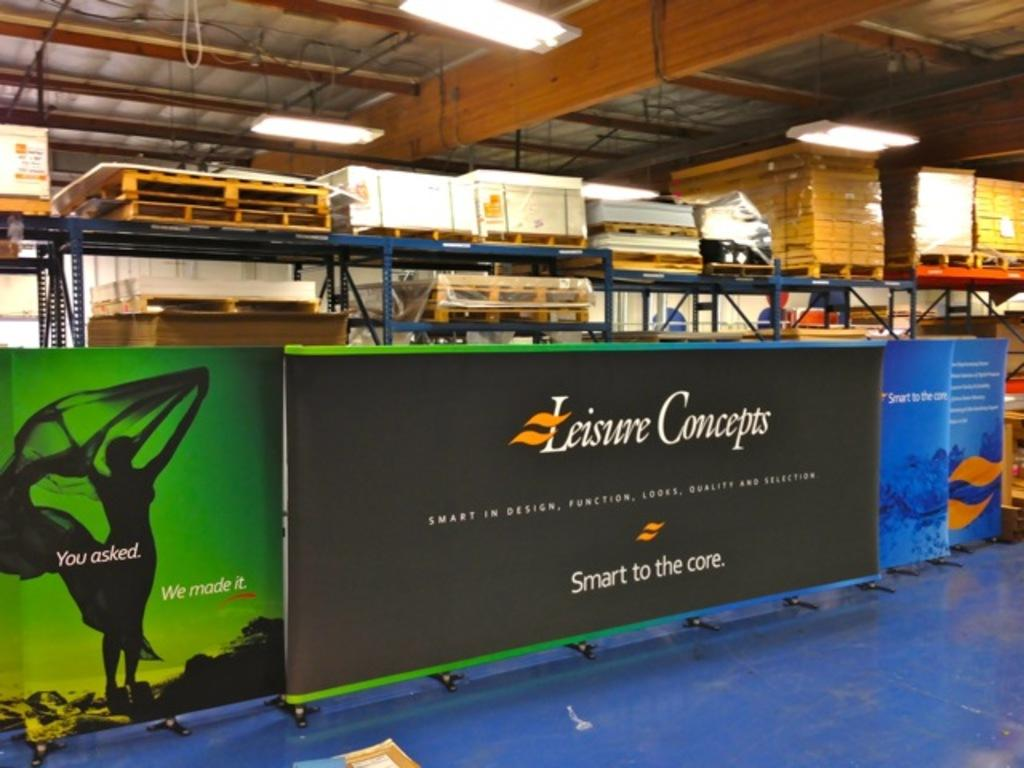What color is the banner in the image? The banner in the image is black. What can be seen in the background of the image? There are objects on a rack and lights hanging from a pole in the background of the image. How many women are driving trucks in the north direction in the image? There are no trucks, women, or any indication of direction in the image. 